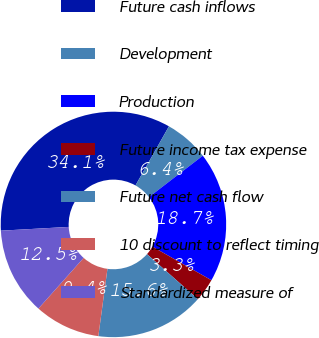Convert chart. <chart><loc_0><loc_0><loc_500><loc_500><pie_chart><fcel>Future cash inflows<fcel>Development<fcel>Production<fcel>Future income tax expense<fcel>Future net cash flow<fcel>10 discount to reflect timing<fcel>Standardized measure of<nl><fcel>34.08%<fcel>6.37%<fcel>18.68%<fcel>3.29%<fcel>15.61%<fcel>9.45%<fcel>12.53%<nl></chart> 